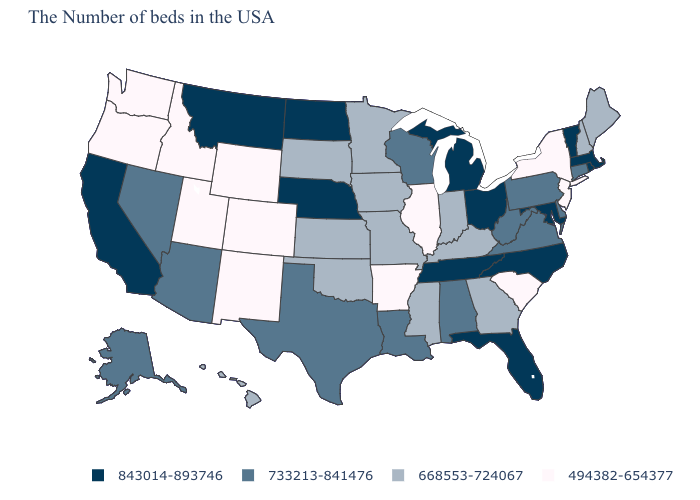What is the value of Kentucky?
Give a very brief answer. 668553-724067. Does the map have missing data?
Keep it brief. No. Which states hav the highest value in the MidWest?
Be succinct. Ohio, Michigan, Nebraska, North Dakota. Does the map have missing data?
Keep it brief. No. Which states have the highest value in the USA?
Concise answer only. Massachusetts, Rhode Island, Vermont, Maryland, North Carolina, Ohio, Florida, Michigan, Tennessee, Nebraska, North Dakota, Montana, California. Name the states that have a value in the range 843014-893746?
Answer briefly. Massachusetts, Rhode Island, Vermont, Maryland, North Carolina, Ohio, Florida, Michigan, Tennessee, Nebraska, North Dakota, Montana, California. Which states have the highest value in the USA?
Answer briefly. Massachusetts, Rhode Island, Vermont, Maryland, North Carolina, Ohio, Florida, Michigan, Tennessee, Nebraska, North Dakota, Montana, California. Does South Carolina have the lowest value in the South?
Short answer required. Yes. Name the states that have a value in the range 494382-654377?
Short answer required. New York, New Jersey, South Carolina, Illinois, Arkansas, Wyoming, Colorado, New Mexico, Utah, Idaho, Washington, Oregon. Which states have the lowest value in the South?
Give a very brief answer. South Carolina, Arkansas. What is the lowest value in states that border Colorado?
Concise answer only. 494382-654377. What is the value of New York?
Keep it brief. 494382-654377. Name the states that have a value in the range 733213-841476?
Answer briefly. Connecticut, Delaware, Pennsylvania, Virginia, West Virginia, Alabama, Wisconsin, Louisiana, Texas, Arizona, Nevada, Alaska. Among the states that border Kansas , does Colorado have the lowest value?
Be succinct. Yes. What is the value of New Jersey?
Quick response, please. 494382-654377. 